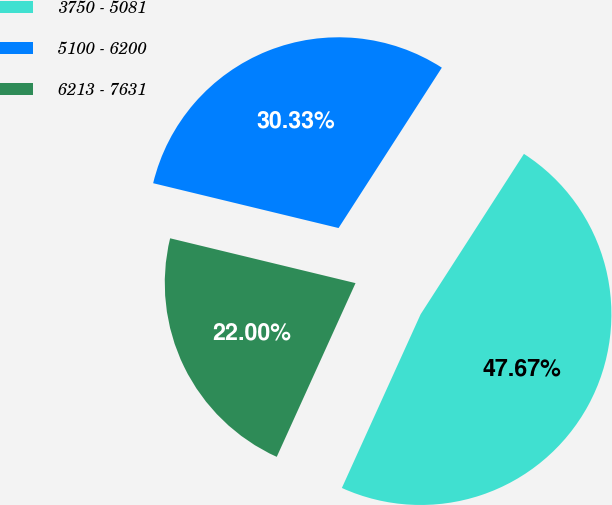<chart> <loc_0><loc_0><loc_500><loc_500><pie_chart><fcel>3750 - 5081<fcel>5100 - 6200<fcel>6213 - 7631<nl><fcel>47.67%<fcel>30.33%<fcel>22.0%<nl></chart> 